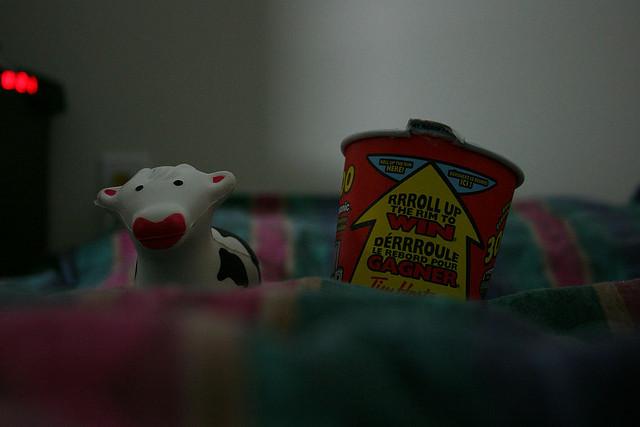Is that a cow?
Write a very short answer. Yes. What animal is portrayed on the object?
Keep it brief. Cow. What type of animal does the toy depict?
Write a very short answer. Cow. What animal is on the basket?
Answer briefly. Cow. What color is the cap for this bottle?
Keep it brief. Black. What color is the arrow on the can?
Give a very brief answer. Yellow. What color are the stripes on the teddy bear?
Concise answer only. Black. What kind of stuffed animals are they?
Short answer required. Cow. If you leave this animal in the car all day, what will happen if it is summer?
Short answer required. Nothing. What numbers are shown in the background?
Keep it brief. 00. What shape is on the ears?
Give a very brief answer. Circle. What fast food restaurant did the man eat at?
Write a very short answer. Gagner. What color are the dolls eyes?
Give a very brief answer. Black. What kind of toy is sitting?
Quick response, please. Cow. What kind of animal is this?
Concise answer only. Cow. Are this dolls stuffed?
Concise answer only. No. What are the toys called?
Quick response, please. Cow. Who would rather play with these toys little girls or little boys?
Answer briefly. Boys. What animal is in the picture?
Keep it brief. Cow. Is there a toy cow?
Keep it brief. Yes. 